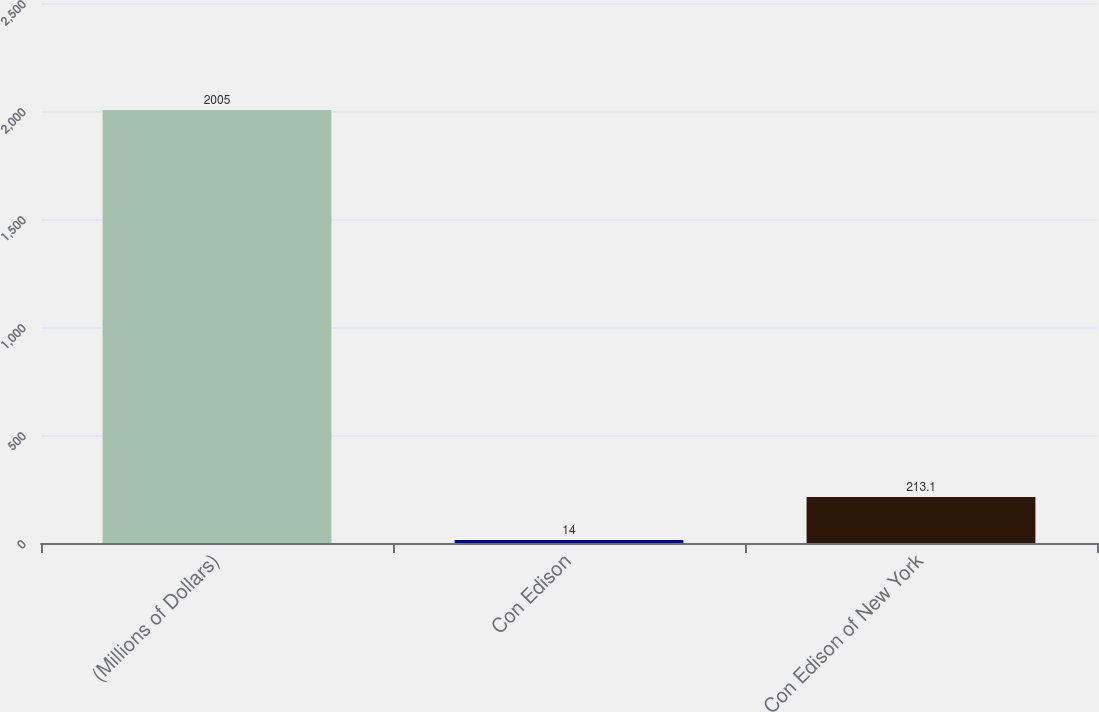Convert chart. <chart><loc_0><loc_0><loc_500><loc_500><bar_chart><fcel>(Millions of Dollars)<fcel>Con Edison<fcel>Con Edison of New York<nl><fcel>2005<fcel>14<fcel>213.1<nl></chart> 